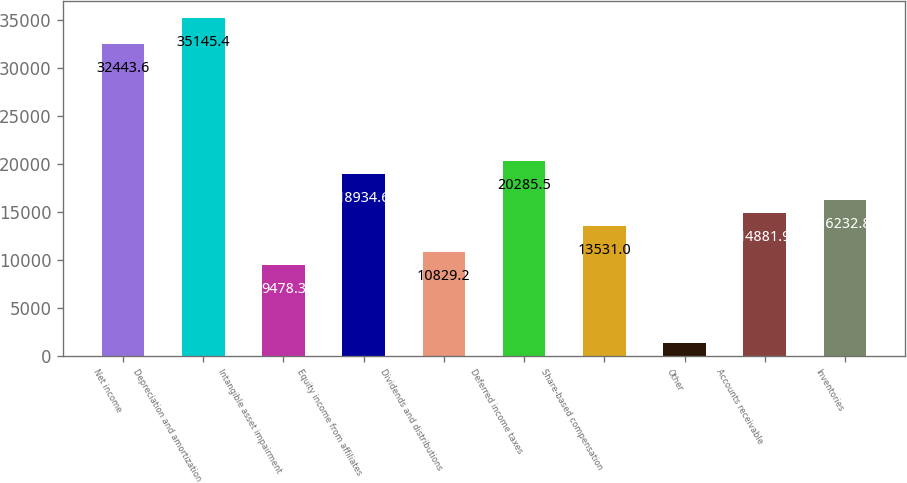Convert chart. <chart><loc_0><loc_0><loc_500><loc_500><bar_chart><fcel>Net income<fcel>Depreciation and amortization<fcel>Intangible asset impairment<fcel>Equity income from affiliates<fcel>Dividends and distributions<fcel>Deferred income taxes<fcel>Share-based compensation<fcel>Other<fcel>Accounts receivable<fcel>Inventories<nl><fcel>32443.6<fcel>35145.4<fcel>9478.3<fcel>18934.6<fcel>10829.2<fcel>20285.5<fcel>13531<fcel>1372.9<fcel>14881.9<fcel>16232.8<nl></chart> 